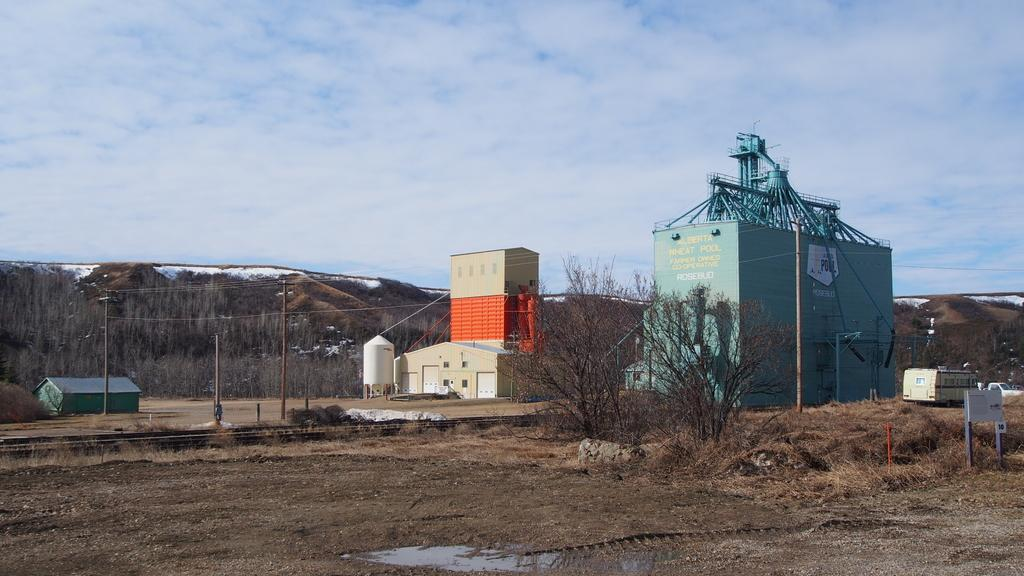What type of structures can be seen in the image? There are buildings in the image. What type of vegetation is present in the image? There are trees in the image. What else can be seen attached to the poles in the image? There are wires attached to the poles in the image. What type of ground surface is visible in the image? There is grass visible in the image. What type of body of water is visible in the image? There is water visible in the image. What animal can be seen on the right side of the image? There is a boar on the right side of the image. What is visible in the background of the image? The sky and hills are visible in the background of the image. What type of suit is the boar wearing in the image? There is no suit present in the image, as the boar is an animal and does not wear clothing. What type of bag is hanging from the boar's throat in the image? There is no bag present in the image, and the boar does not have a throat like humans do. 